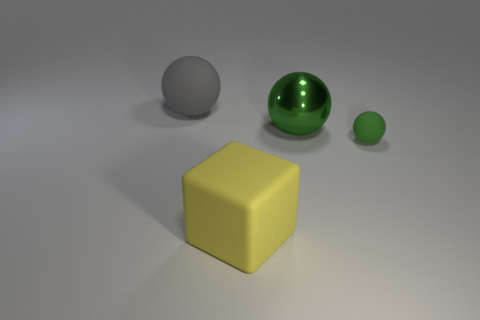Add 1 large gray blocks. How many objects exist? 5 Subtract all cubes. How many objects are left? 3 Add 2 big purple shiny spheres. How many big purple shiny spheres exist? 2 Subtract 2 green balls. How many objects are left? 2 Subtract all big gray matte balls. Subtract all big green metallic balls. How many objects are left? 2 Add 2 tiny green matte spheres. How many tiny green matte spheres are left? 3 